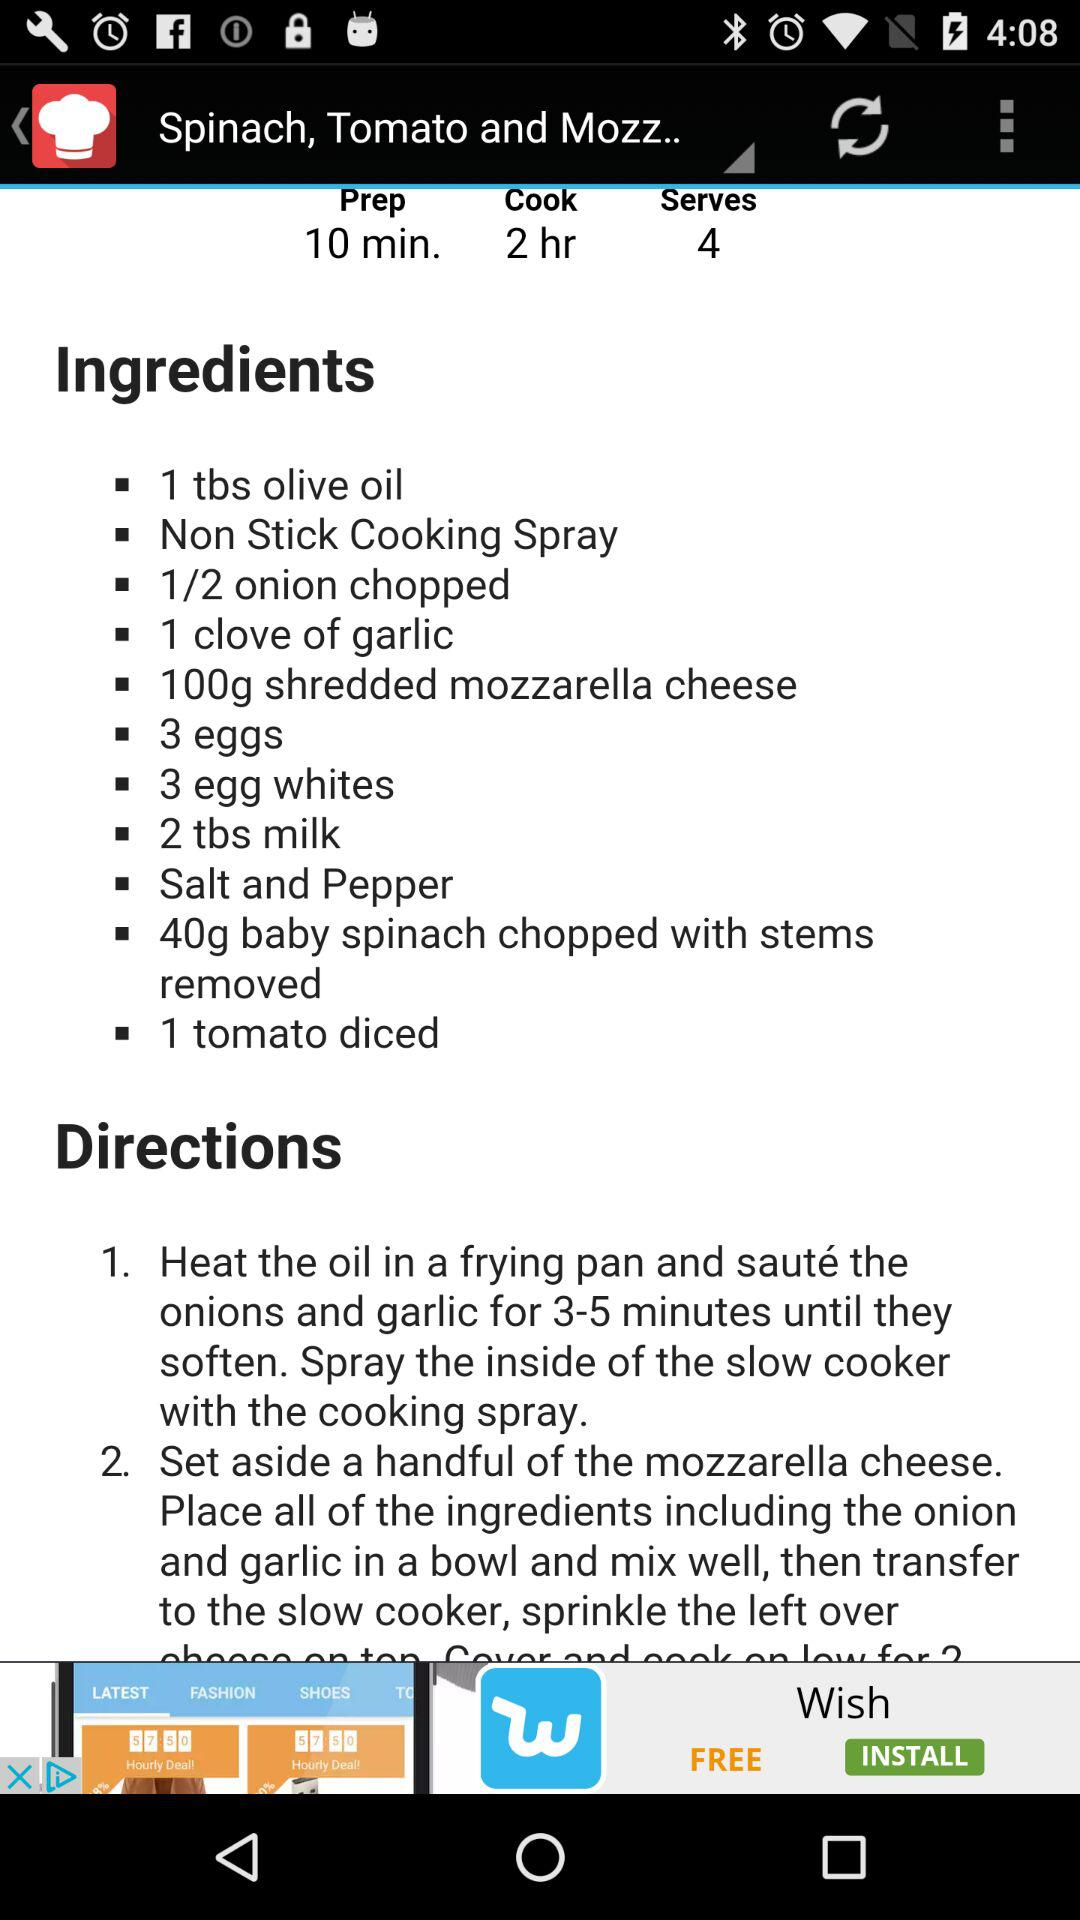How much time will it take to make the dish? It will take 10 minutes to make a dish. 